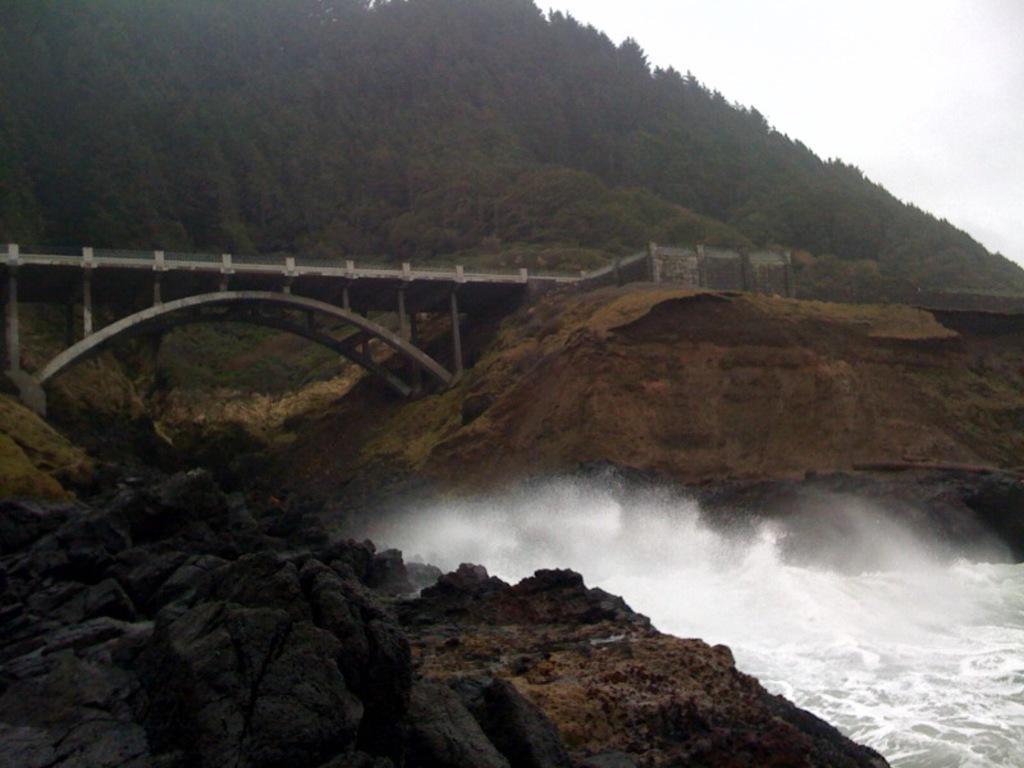How would you summarize this image in a sentence or two? In this picture there is a bridge and there are trees on the mountain. In the foreground there are rocks. At the top there is sky. At the bottom there is water. 